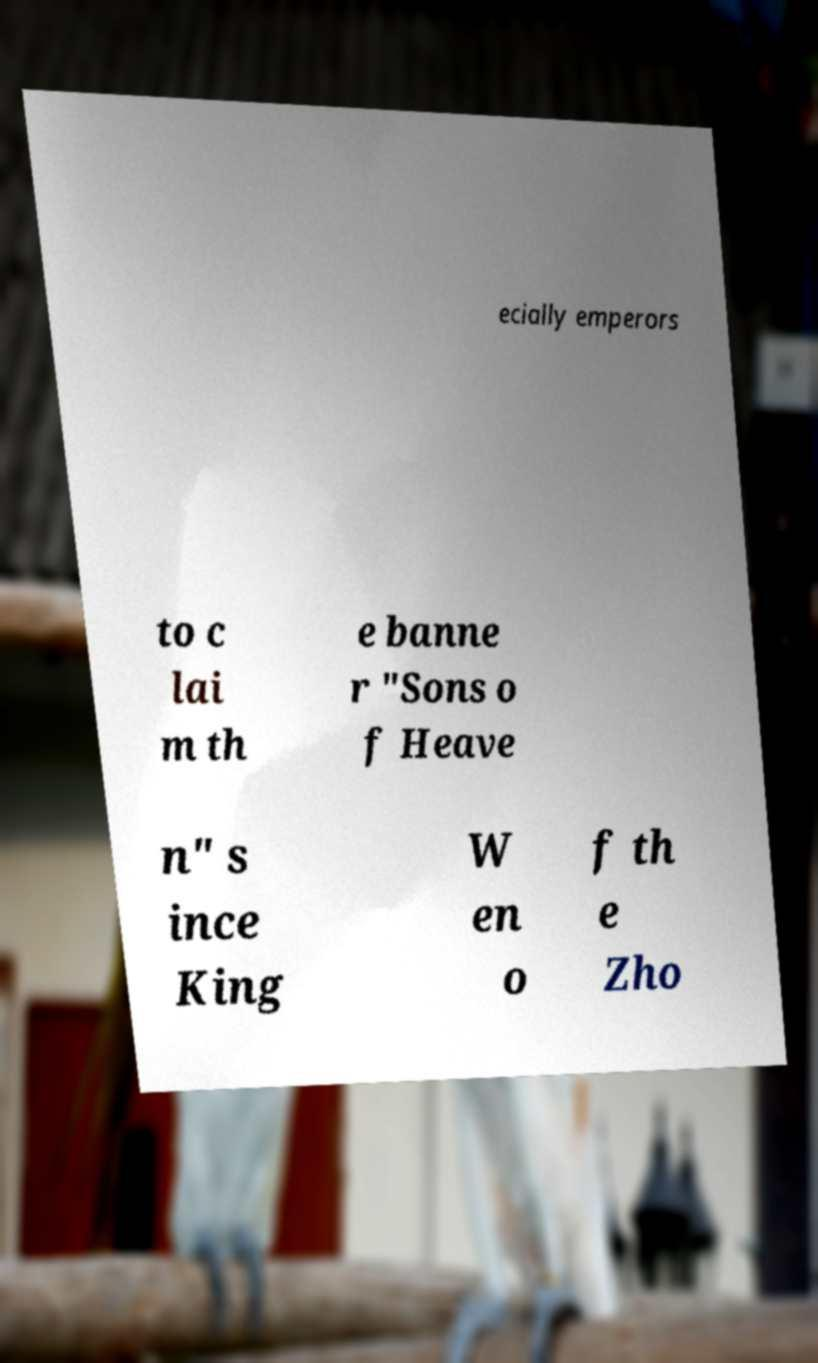Please identify and transcribe the text found in this image. ecially emperors to c lai m th e banne r "Sons o f Heave n" s ince King W en o f th e Zho 